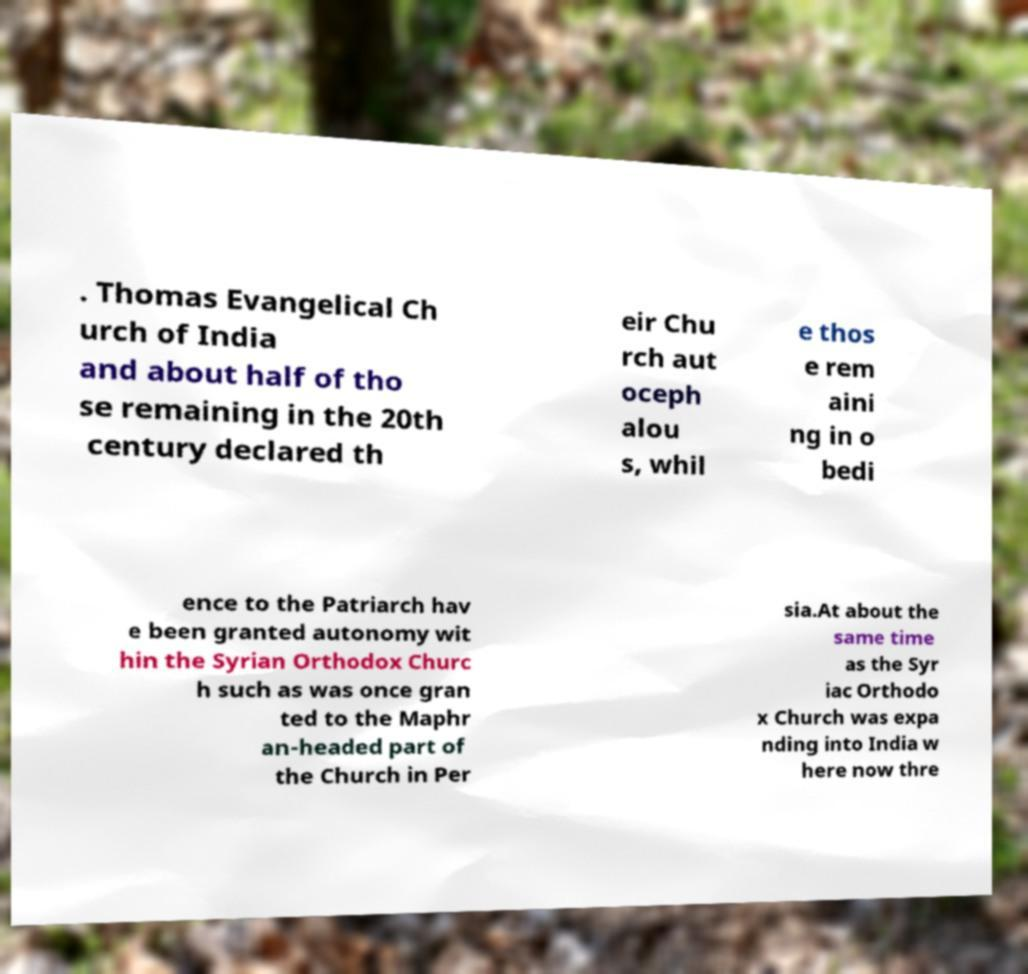For documentation purposes, I need the text within this image transcribed. Could you provide that? . Thomas Evangelical Ch urch of India and about half of tho se remaining in the 20th century declared th eir Chu rch aut oceph alou s, whil e thos e rem aini ng in o bedi ence to the Patriarch hav e been granted autonomy wit hin the Syrian Orthodox Churc h such as was once gran ted to the Maphr an-headed part of the Church in Per sia.At about the same time as the Syr iac Orthodo x Church was expa nding into India w here now thre 